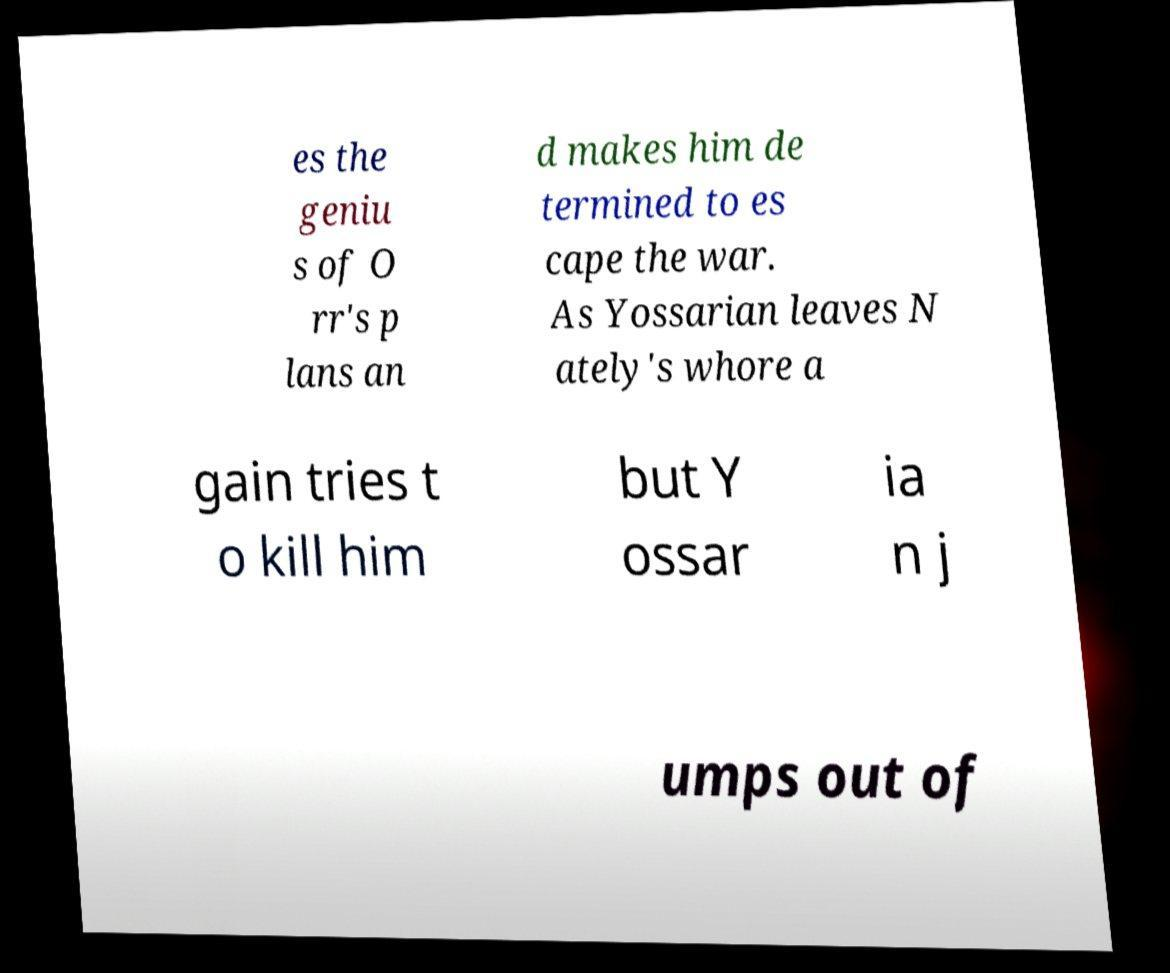Please read and relay the text visible in this image. What does it say? es the geniu s of O rr's p lans an d makes him de termined to es cape the war. As Yossarian leaves N ately's whore a gain tries t o kill him but Y ossar ia n j umps out of 